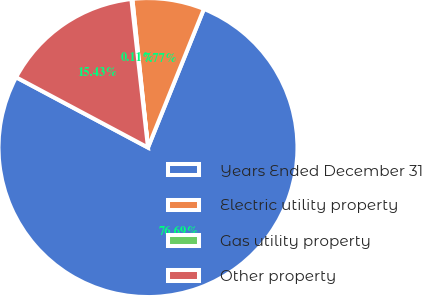<chart> <loc_0><loc_0><loc_500><loc_500><pie_chart><fcel>Years Ended December 31<fcel>Electric utility property<fcel>Gas utility property<fcel>Other property<nl><fcel>76.7%<fcel>7.77%<fcel>0.11%<fcel>15.43%<nl></chart> 